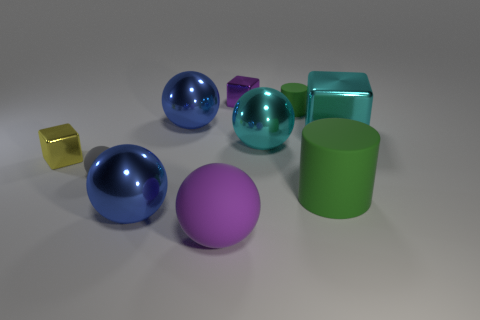Subtract all tiny cubes. How many cubes are left? 1 Subtract all cyan cubes. How many cubes are left? 2 Subtract all cubes. How many objects are left? 7 Subtract all purple spheres. Subtract all purple blocks. How many spheres are left? 4 Subtract all green cubes. How many brown cylinders are left? 0 Subtract all large red shiny cubes. Subtract all large green rubber things. How many objects are left? 9 Add 4 big blue spheres. How many big blue spheres are left? 6 Add 3 small purple shiny things. How many small purple shiny things exist? 4 Subtract 0 red balls. How many objects are left? 10 Subtract 3 spheres. How many spheres are left? 2 